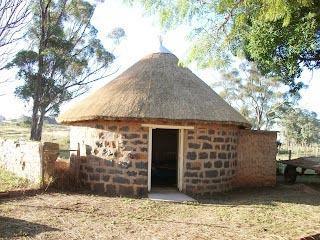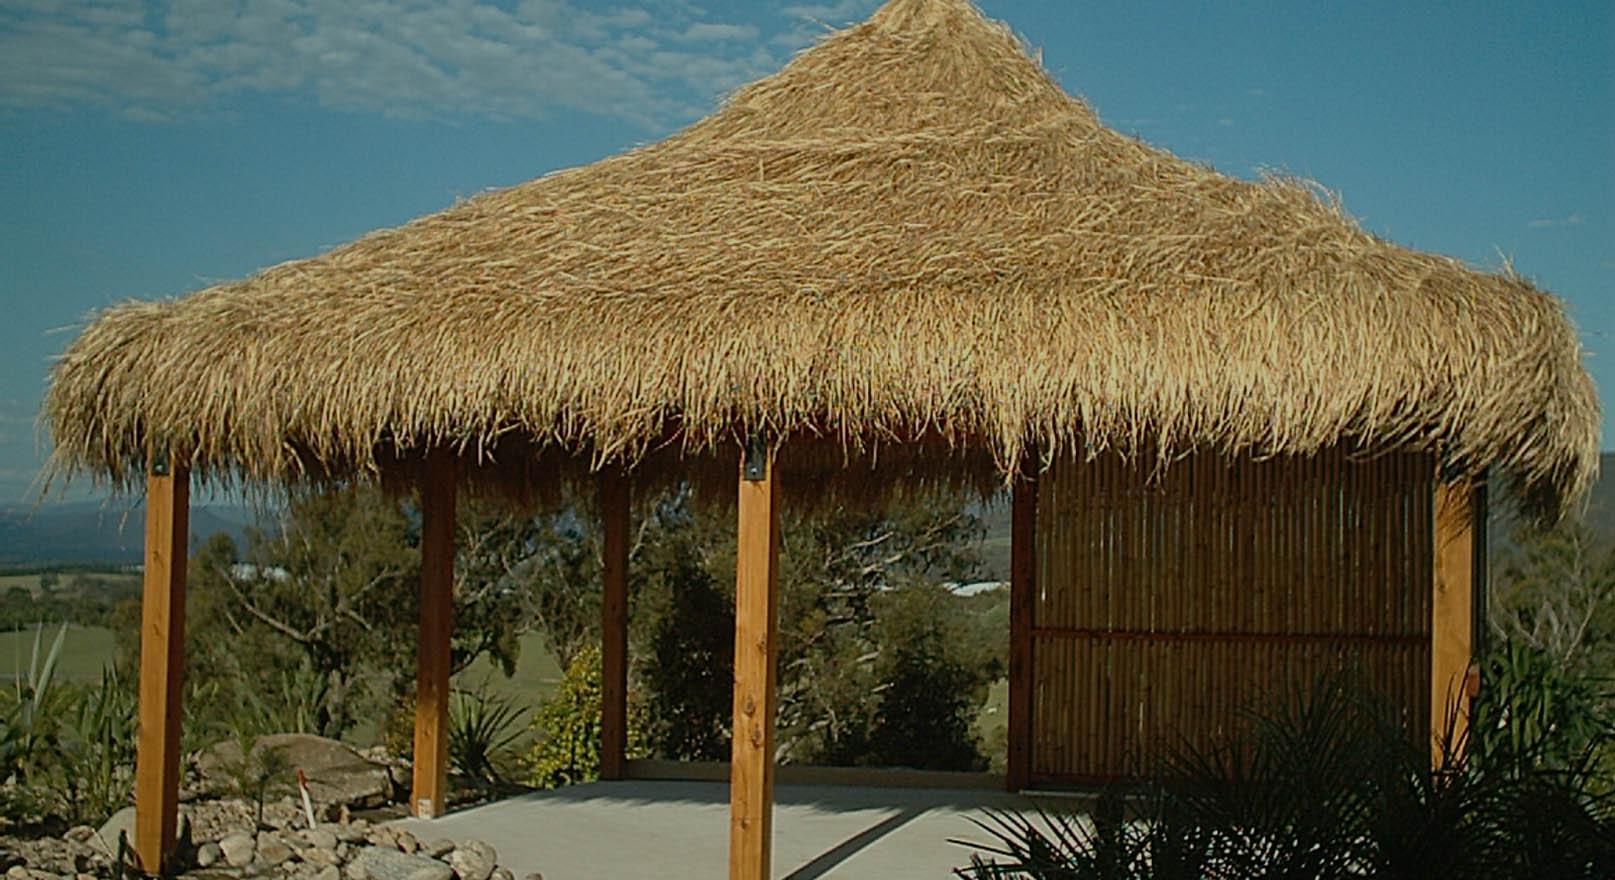The first image is the image on the left, the second image is the image on the right. Considering the images on both sides, is "One of these is an open canopy over a deck area - it's not for dwelling, cooking, or sleeping." valid? Answer yes or no. Yes. The first image is the image on the left, the second image is the image on the right. Evaluate the accuracy of this statement regarding the images: "The left image includes a peaked thatch roof with an even bottom edge and a gray cap on its tip, held up by corner posts.". Is it true? Answer yes or no. No. 